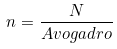<formula> <loc_0><loc_0><loc_500><loc_500>n = \frac { N } { A v o g a d r o }</formula> 